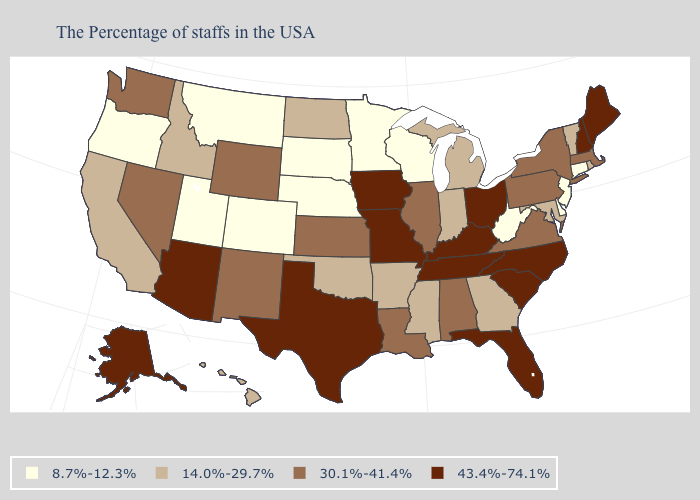What is the highest value in states that border Maine?
Be succinct. 43.4%-74.1%. What is the highest value in the West ?
Keep it brief. 43.4%-74.1%. What is the value of New Mexico?
Answer briefly. 30.1%-41.4%. Is the legend a continuous bar?
Write a very short answer. No. What is the highest value in states that border Mississippi?
Keep it brief. 43.4%-74.1%. What is the lowest value in the USA?
Write a very short answer. 8.7%-12.3%. Name the states that have a value in the range 30.1%-41.4%?
Quick response, please. Massachusetts, New York, Pennsylvania, Virginia, Alabama, Illinois, Louisiana, Kansas, Wyoming, New Mexico, Nevada, Washington. Name the states that have a value in the range 43.4%-74.1%?
Concise answer only. Maine, New Hampshire, North Carolina, South Carolina, Ohio, Florida, Kentucky, Tennessee, Missouri, Iowa, Texas, Arizona, Alaska. Name the states that have a value in the range 43.4%-74.1%?
Be succinct. Maine, New Hampshire, North Carolina, South Carolina, Ohio, Florida, Kentucky, Tennessee, Missouri, Iowa, Texas, Arizona, Alaska. Among the states that border Wyoming , which have the lowest value?
Be succinct. Nebraska, South Dakota, Colorado, Utah, Montana. Name the states that have a value in the range 43.4%-74.1%?
Give a very brief answer. Maine, New Hampshire, North Carolina, South Carolina, Ohio, Florida, Kentucky, Tennessee, Missouri, Iowa, Texas, Arizona, Alaska. Among the states that border Vermont , which have the lowest value?
Be succinct. Massachusetts, New York. Name the states that have a value in the range 14.0%-29.7%?
Concise answer only. Rhode Island, Vermont, Maryland, Georgia, Michigan, Indiana, Mississippi, Arkansas, Oklahoma, North Dakota, Idaho, California, Hawaii. Among the states that border Oklahoma , does Kansas have the highest value?
Answer briefly. No. What is the highest value in states that border Nebraska?
Concise answer only. 43.4%-74.1%. 